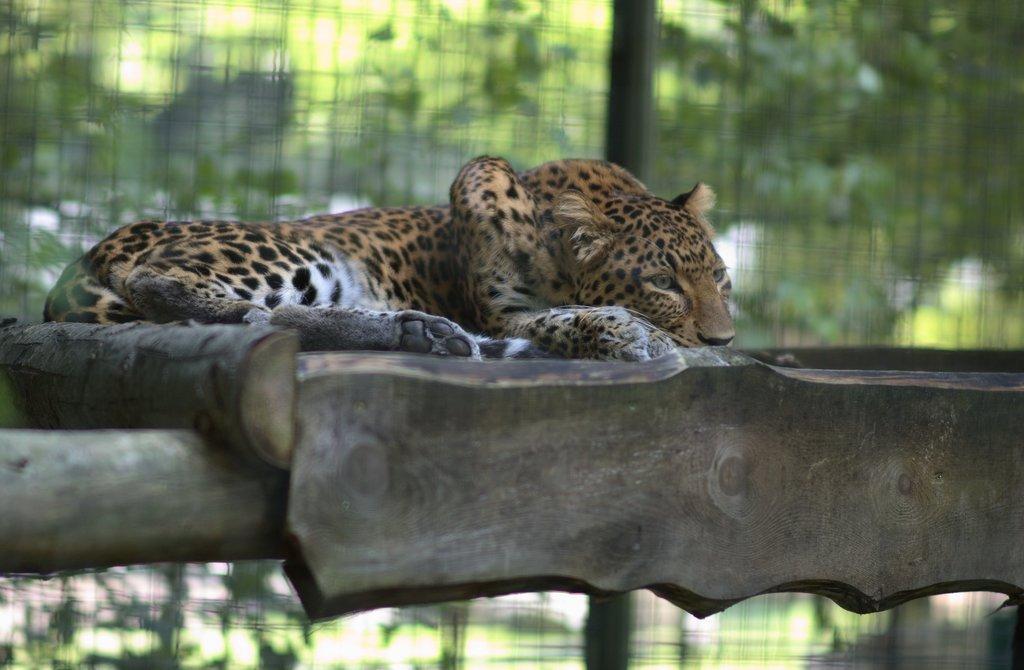Please provide a concise description of this image. In this image I see a leopard which is lying on the wooden thing and I see that it is blurred in the background. 